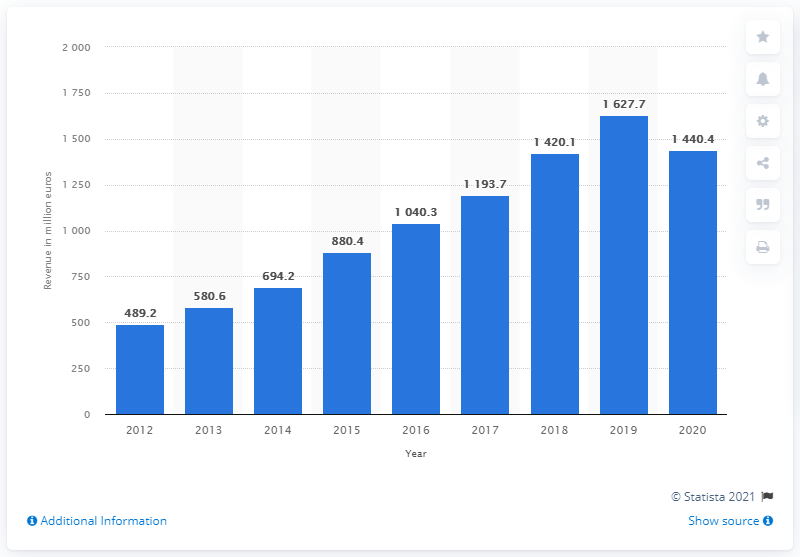Identify some key points in this picture. Moncler's global revenue in the most recent period was 1440.4 million. 